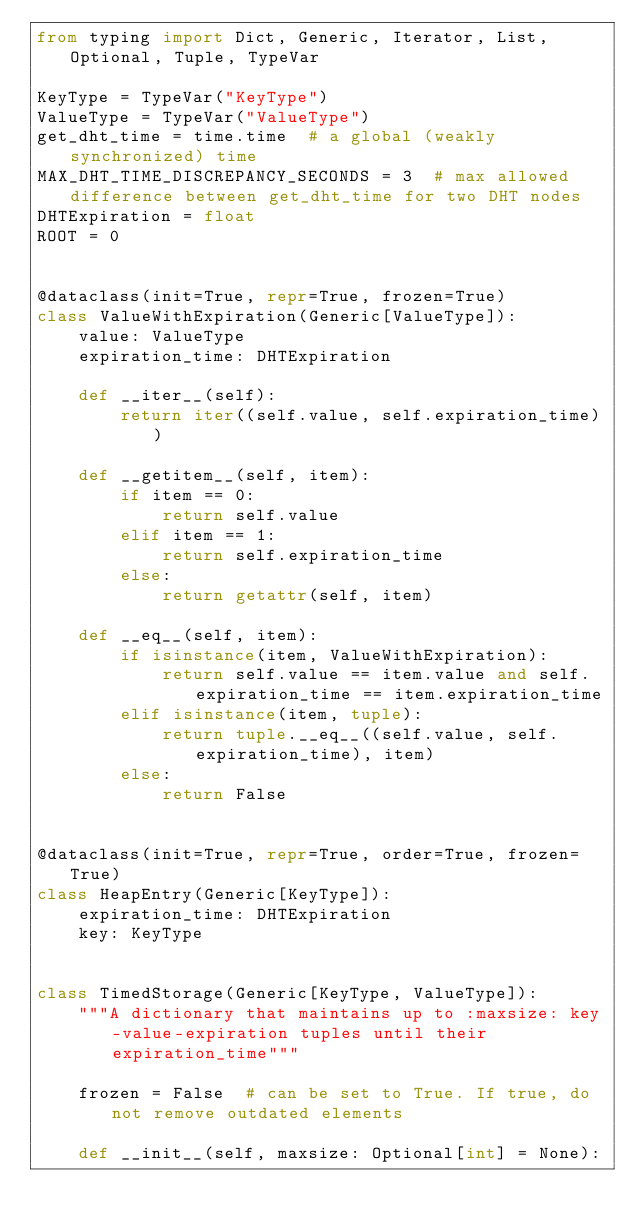Convert code to text. <code><loc_0><loc_0><loc_500><loc_500><_Python_>from typing import Dict, Generic, Iterator, List, Optional, Tuple, TypeVar

KeyType = TypeVar("KeyType")
ValueType = TypeVar("ValueType")
get_dht_time = time.time  # a global (weakly synchronized) time
MAX_DHT_TIME_DISCREPANCY_SECONDS = 3  # max allowed difference between get_dht_time for two DHT nodes
DHTExpiration = float
ROOT = 0


@dataclass(init=True, repr=True, frozen=True)
class ValueWithExpiration(Generic[ValueType]):
    value: ValueType
    expiration_time: DHTExpiration

    def __iter__(self):
        return iter((self.value, self.expiration_time))

    def __getitem__(self, item):
        if item == 0:
            return self.value
        elif item == 1:
            return self.expiration_time
        else:
            return getattr(self, item)

    def __eq__(self, item):
        if isinstance(item, ValueWithExpiration):
            return self.value == item.value and self.expiration_time == item.expiration_time
        elif isinstance(item, tuple):
            return tuple.__eq__((self.value, self.expiration_time), item)
        else:
            return False


@dataclass(init=True, repr=True, order=True, frozen=True)
class HeapEntry(Generic[KeyType]):
    expiration_time: DHTExpiration
    key: KeyType


class TimedStorage(Generic[KeyType, ValueType]):
    """A dictionary that maintains up to :maxsize: key-value-expiration tuples until their expiration_time"""

    frozen = False  # can be set to True. If true, do not remove outdated elements

    def __init__(self, maxsize: Optional[int] = None):</code> 